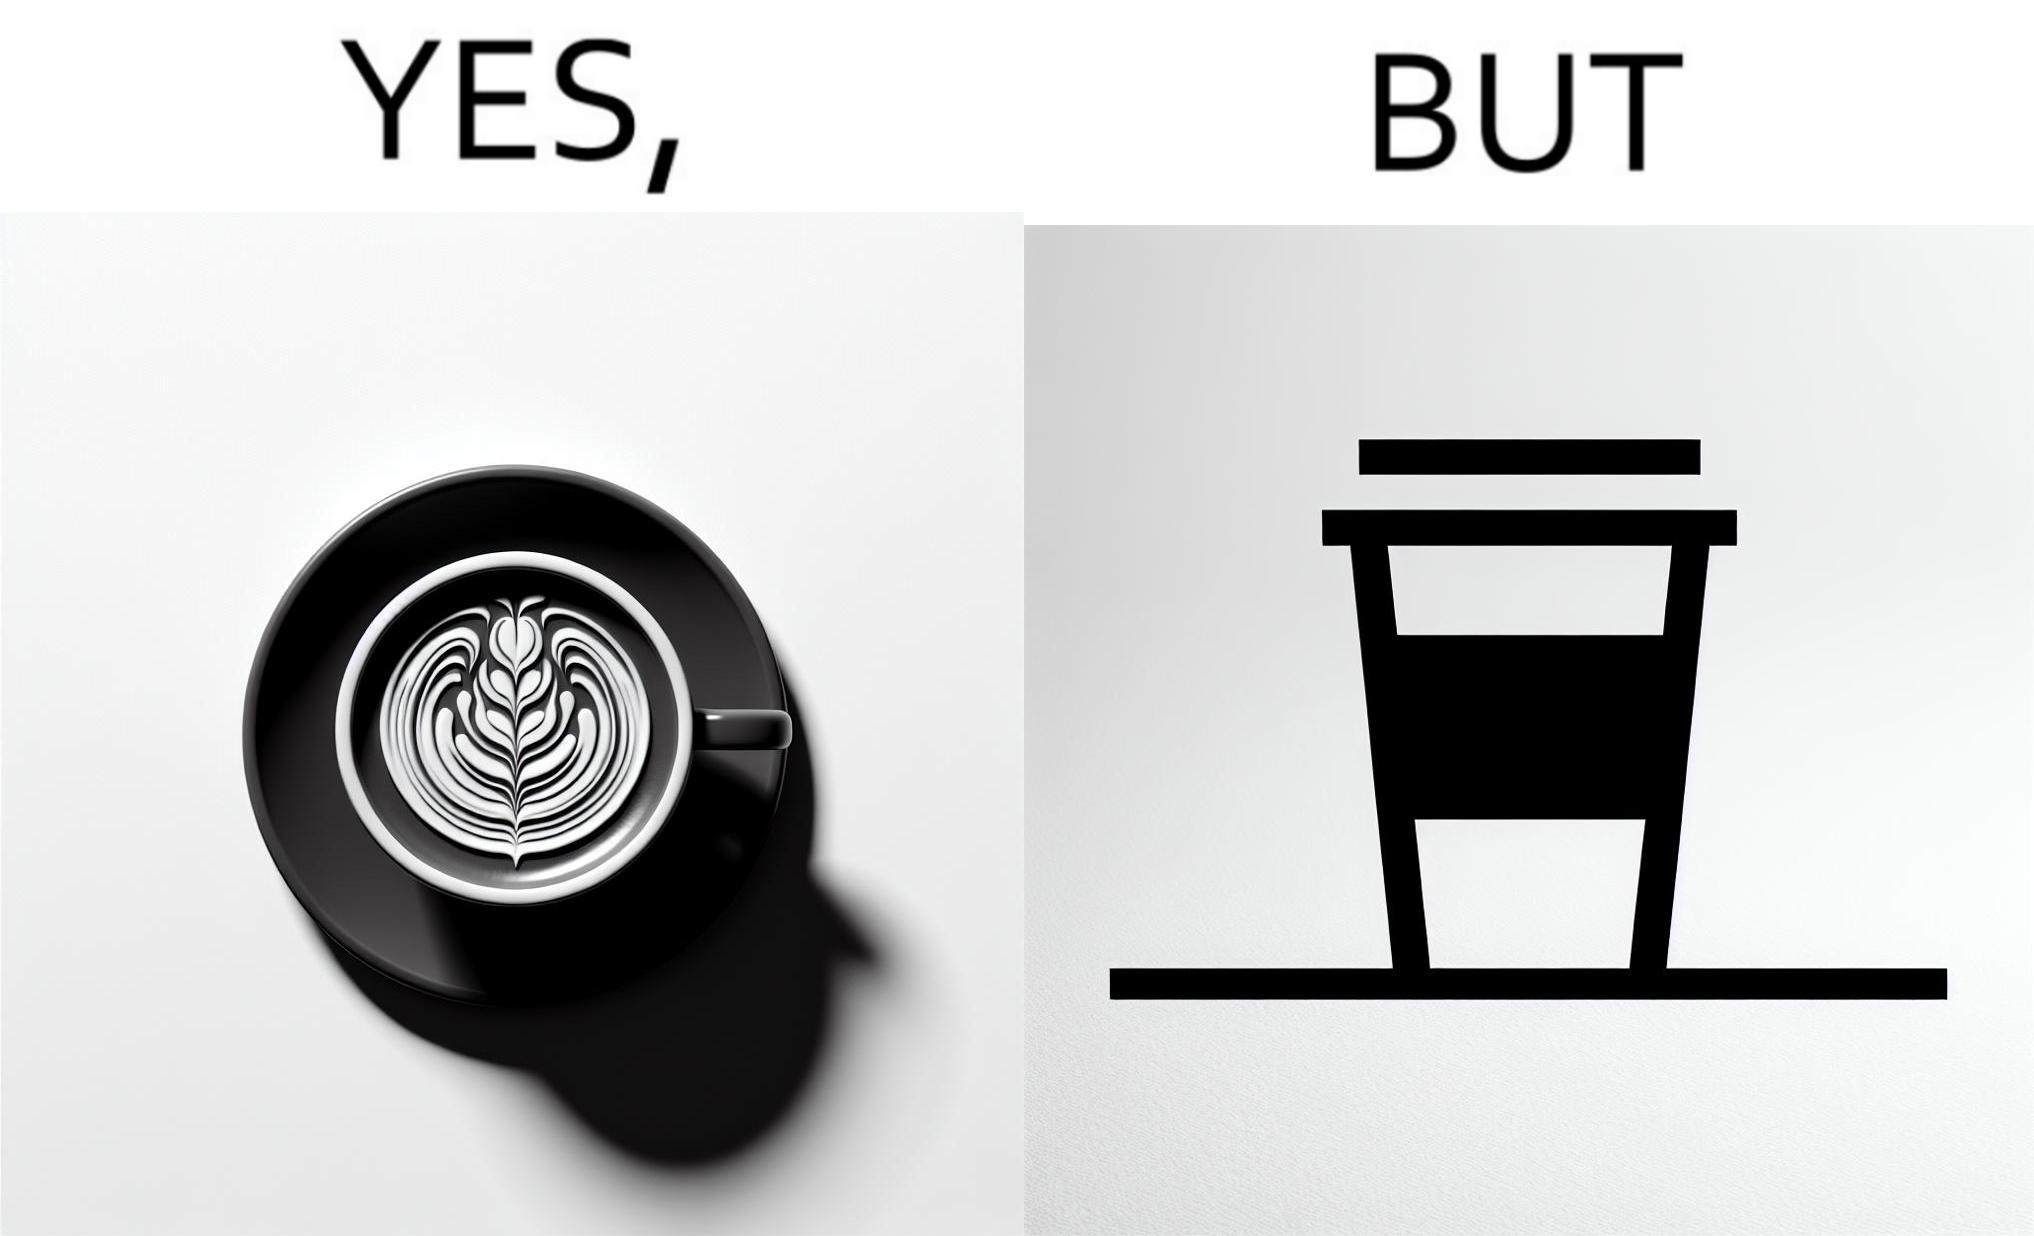Is this image satirical or non-satirical? Yes, this image is satirical. 